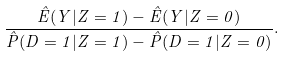<formula> <loc_0><loc_0><loc_500><loc_500>\frac { \hat { E } ( Y | Z = 1 ) - \hat { E } ( Y | Z = 0 ) } { \hat { P } ( D = 1 | Z = 1 ) - \hat { P } ( D = 1 | Z = 0 ) } .</formula> 